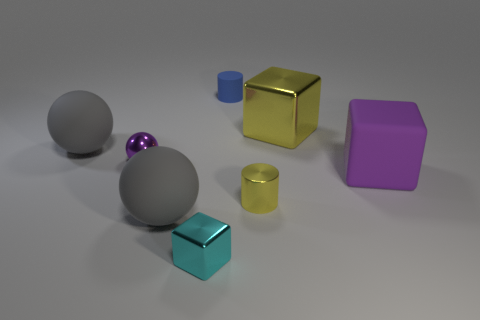Is there anything else that has the same material as the tiny yellow object?
Provide a succinct answer. Yes. Are there any tiny yellow cylinders that are behind the cube behind the large purple matte cube?
Provide a short and direct response. No. How many things are either big things that are to the left of the blue object or shiny blocks on the right side of the tiny cyan cube?
Give a very brief answer. 3. Is there anything else of the same color as the tiny metal block?
Ensure brevity in your answer.  No. There is a big rubber object that is to the right of the gray ball in front of the tiny yellow metal cylinder that is right of the small purple shiny thing; what is its color?
Your answer should be compact. Purple. How big is the yellow metal thing that is in front of the matte sphere that is behind the small metallic cylinder?
Make the answer very short. Small. What is the small object that is left of the matte cylinder and in front of the large matte block made of?
Provide a short and direct response. Metal. There is a purple metallic object; is it the same size as the block that is in front of the big purple matte thing?
Provide a short and direct response. Yes. Are any big brown objects visible?
Ensure brevity in your answer.  No. There is another tiny object that is the same shape as the small rubber thing; what is its material?
Provide a short and direct response. Metal. 